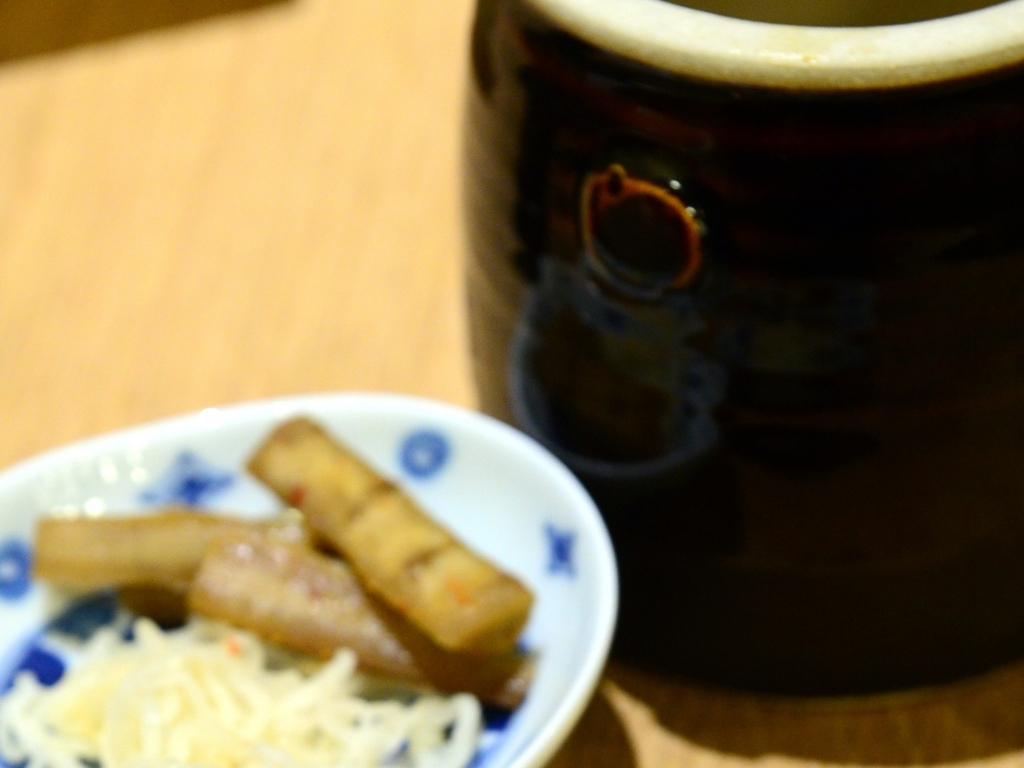What issue does this image have?
A. The image has excellent sharpness and focusing.
B. The image has average sharpness and focusing.
C. The image has a general lack of sharpness and focusing issue. Option C is correct. The image appears to have a general lack of sharpness and focusing issue. The foreground is blurry and there is no discernible area of the image that is in sharp focus, indicating that the camera may not have been focused correctly when the photograph was taken. When capturing images, it is essential to ensure the camera focus is set appropriately to avoid such problems, which may detract from the quality and detail of the photographed subjects. 